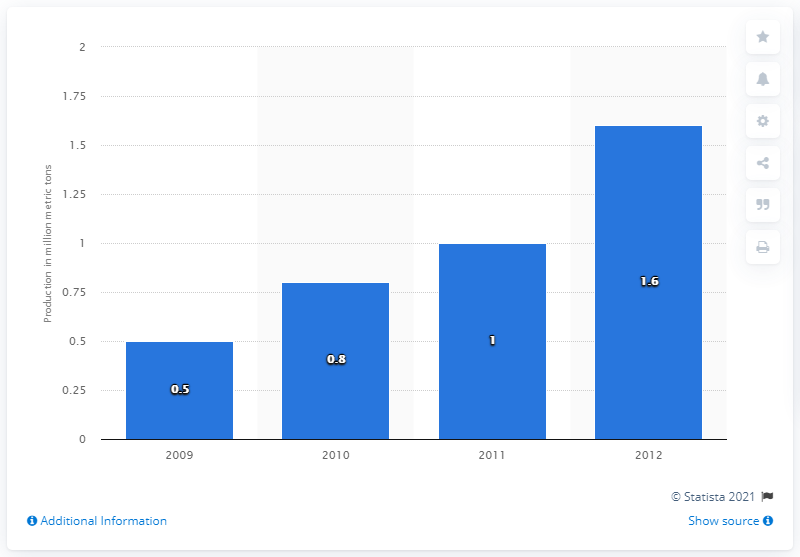Give some essential details in this illustration. The last year of wood pellet imports from the Southeastern United States into the 27 member states of the EU was 2012. 